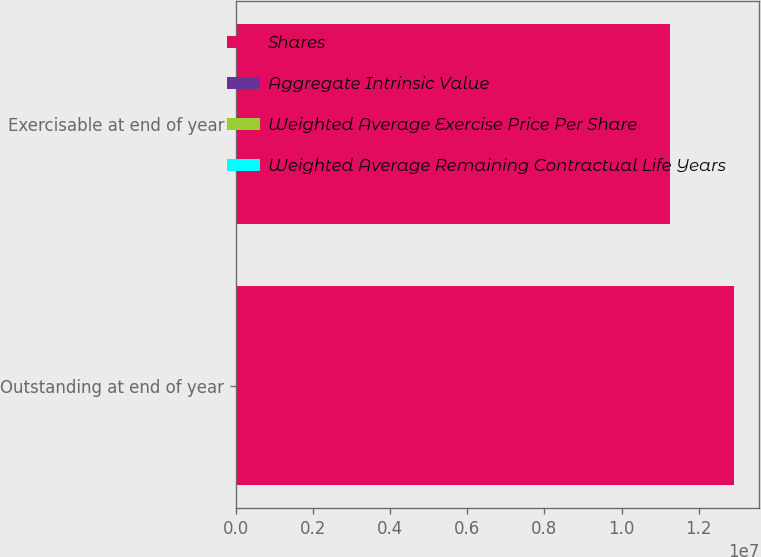Convert chart. <chart><loc_0><loc_0><loc_500><loc_500><stacked_bar_chart><ecel><fcel>Outstanding at end of year<fcel>Exercisable at end of year<nl><fcel>Shares<fcel>1.29259e+07<fcel>1.12496e+07<nl><fcel>Aggregate Intrinsic Value<fcel>73.44<fcel>72.94<nl><fcel>Weighted Average Exercise Price Per Share<fcel>5.23<fcel>4.93<nl><fcel>Weighted Average Remaining Contractual Life Years<fcel>920<fcel>806<nl></chart> 